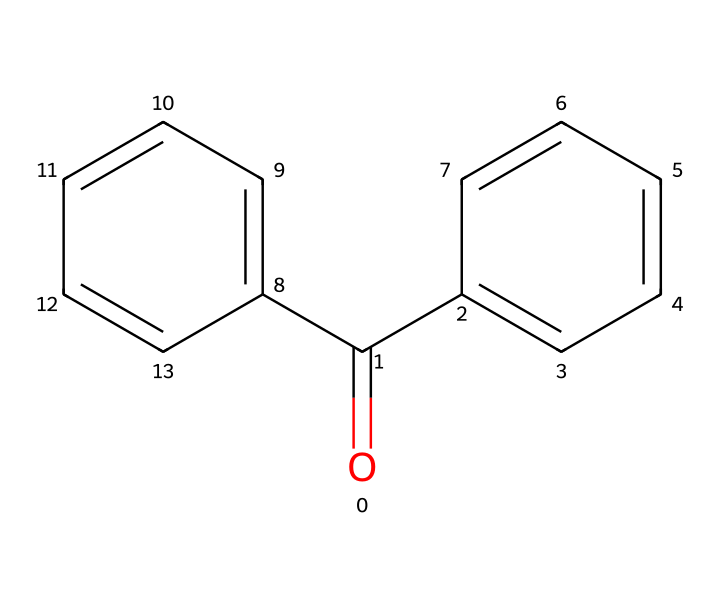What is the functional group present in benzophenone? The chemical structure of benzophenone includes a carbonyl group (C=O) that characterizes ketones.
Answer: carbonyl How many aromatic rings are present in benzophenone? The structure shows two phenyl rings bonded to the carbonyl group, indicating two aromatic rings in total.
Answer: two What is the total number of carbon atoms in benzophenone? Counting the carbon atoms, there are 13 carbon atoms in the structure: 11 from the two phenyl rings and 2 from the carbonyl group.
Answer: thirteen Which molecular formula corresponds to benzophenone? The chemical structure can be distilled down to the molecular formula consisting of the counted atoms, leading to C13H10O.
Answer: C13H10O What characteristic of ketones does benzophenone exhibit due to its molecular arrangement? Benzophenone exhibits a distinct reactivity associated with ketones, particularly the property of being a good UV absorber due to the presence of the carbonyl functional group.
Answer: UV absorber How does the bonding arrangement of benzophenone relate to its application in UV-curing inks? The planar structure of benzophenone allows for effective interaction with UV light, aiding in the curing process, which is crucial for its utility in inks used for secure printing processes like ballots.
Answer: planar structure What type of compound is benzophenone classified as? With its carbonyl group and specific molecular structure, benzophenone is classified as a ketone.
Answer: ketone 